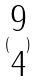<formula> <loc_0><loc_0><loc_500><loc_500>( \begin{matrix} 9 \\ 4 \end{matrix} )</formula> 